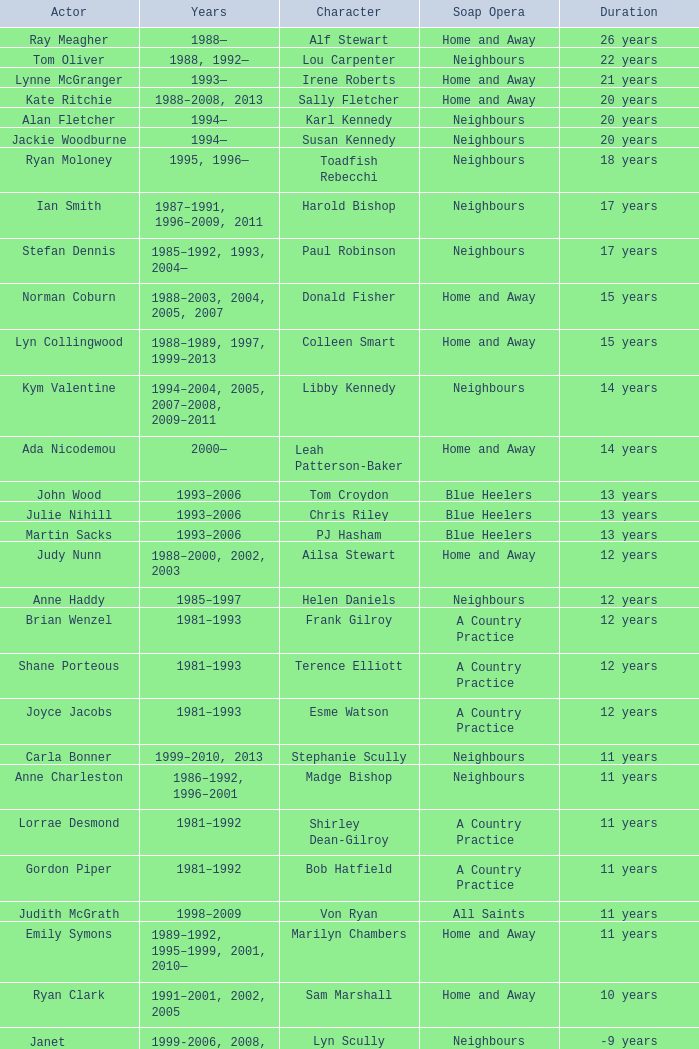Which years did Martin Sacks work on a soap opera? 1993–2006. 